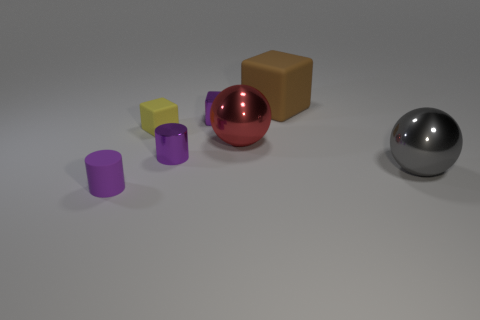What is the size of the purple metal cube?
Make the answer very short. Small. Are the brown block and the red thing made of the same material?
Your answer should be very brief. No. There is another sphere that is the same size as the gray ball; what is its material?
Give a very brief answer. Metal. What number of things are rubber objects that are left of the brown cube or small things?
Offer a very short reply. 4. Are there the same number of purple matte cylinders to the right of the red shiny ball and cyan metallic cubes?
Offer a very short reply. Yes. Is the tiny metal cube the same color as the tiny rubber cylinder?
Your answer should be compact. Yes. What is the color of the tiny object that is to the right of the small rubber cube and in front of the purple block?
Make the answer very short. Purple. What number of blocks are either purple metallic things or large brown rubber things?
Keep it short and to the point. 2. Are there fewer metallic objects that are on the right side of the big gray shiny thing than purple rubber things?
Offer a terse response. Yes. There is a big gray object that is the same material as the large red sphere; what shape is it?
Give a very brief answer. Sphere. 